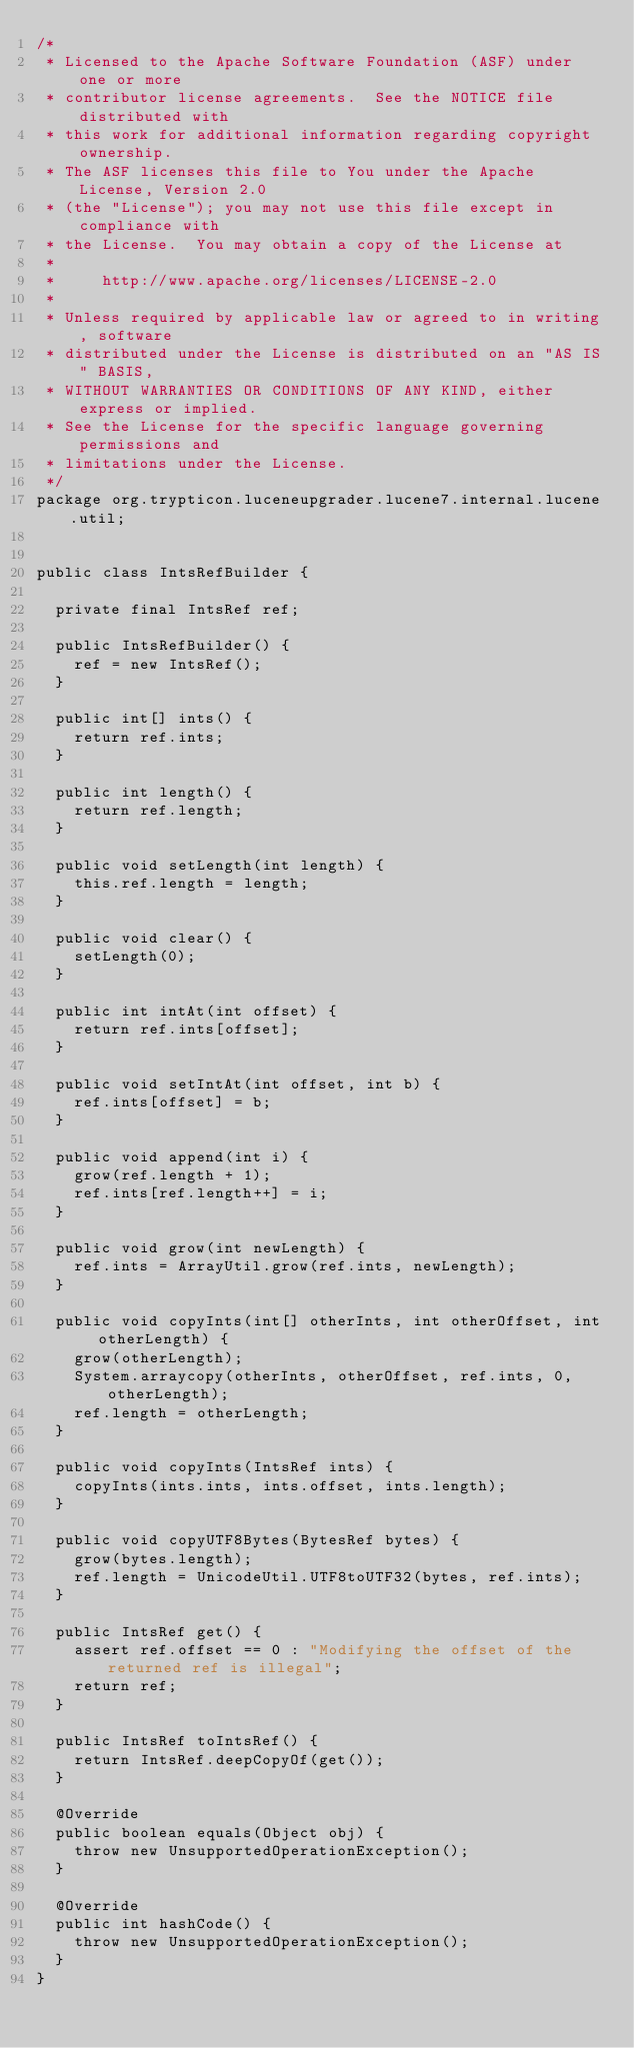<code> <loc_0><loc_0><loc_500><loc_500><_Java_>/*
 * Licensed to the Apache Software Foundation (ASF) under one or more
 * contributor license agreements.  See the NOTICE file distributed with
 * this work for additional information regarding copyright ownership.
 * The ASF licenses this file to You under the Apache License, Version 2.0
 * (the "License"); you may not use this file except in compliance with
 * the License.  You may obtain a copy of the License at
 *
 *     http://www.apache.org/licenses/LICENSE-2.0
 *
 * Unless required by applicable law or agreed to in writing, software
 * distributed under the License is distributed on an "AS IS" BASIS,
 * WITHOUT WARRANTIES OR CONDITIONS OF ANY KIND, either express or implied.
 * See the License for the specific language governing permissions and
 * limitations under the License.
 */
package org.trypticon.luceneupgrader.lucene7.internal.lucene.util;


public class IntsRefBuilder {

  private final IntsRef ref;

  public IntsRefBuilder() {
    ref = new IntsRef();
  }

  public int[] ints() {
    return ref.ints;
  }

  public int length() {
    return ref.length;
  }

  public void setLength(int length) {
    this.ref.length = length;
  }

  public void clear() {
    setLength(0);
  }

  public int intAt(int offset) {
    return ref.ints[offset];
  }

  public void setIntAt(int offset, int b) {
    ref.ints[offset] = b;
  }

  public void append(int i) {
    grow(ref.length + 1);
    ref.ints[ref.length++] = i;
  }

  public void grow(int newLength) {
    ref.ints = ArrayUtil.grow(ref.ints, newLength);
  }

  public void copyInts(int[] otherInts, int otherOffset, int otherLength) {
    grow(otherLength);
    System.arraycopy(otherInts, otherOffset, ref.ints, 0, otherLength);
    ref.length = otherLength;
  }

  public void copyInts(IntsRef ints) {
    copyInts(ints.ints, ints.offset, ints.length);
  }

  public void copyUTF8Bytes(BytesRef bytes) {
    grow(bytes.length);
    ref.length = UnicodeUtil.UTF8toUTF32(bytes, ref.ints);
  }

  public IntsRef get() {
    assert ref.offset == 0 : "Modifying the offset of the returned ref is illegal";
    return ref;
  }

  public IntsRef toIntsRef() {
    return IntsRef.deepCopyOf(get());
  }

  @Override
  public boolean equals(Object obj) {
    throw new UnsupportedOperationException();
  }

  @Override
  public int hashCode() {
    throw new UnsupportedOperationException();
  }
}
</code> 